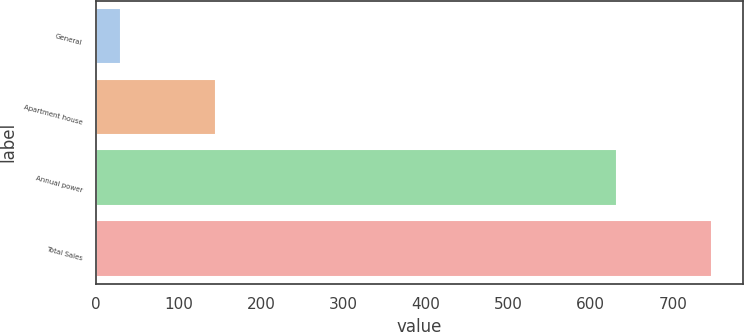<chart> <loc_0><loc_0><loc_500><loc_500><bar_chart><fcel>General<fcel>Apartment house<fcel>Annual power<fcel>Total Sales<nl><fcel>30<fcel>146<fcel>632<fcel>748<nl></chart> 